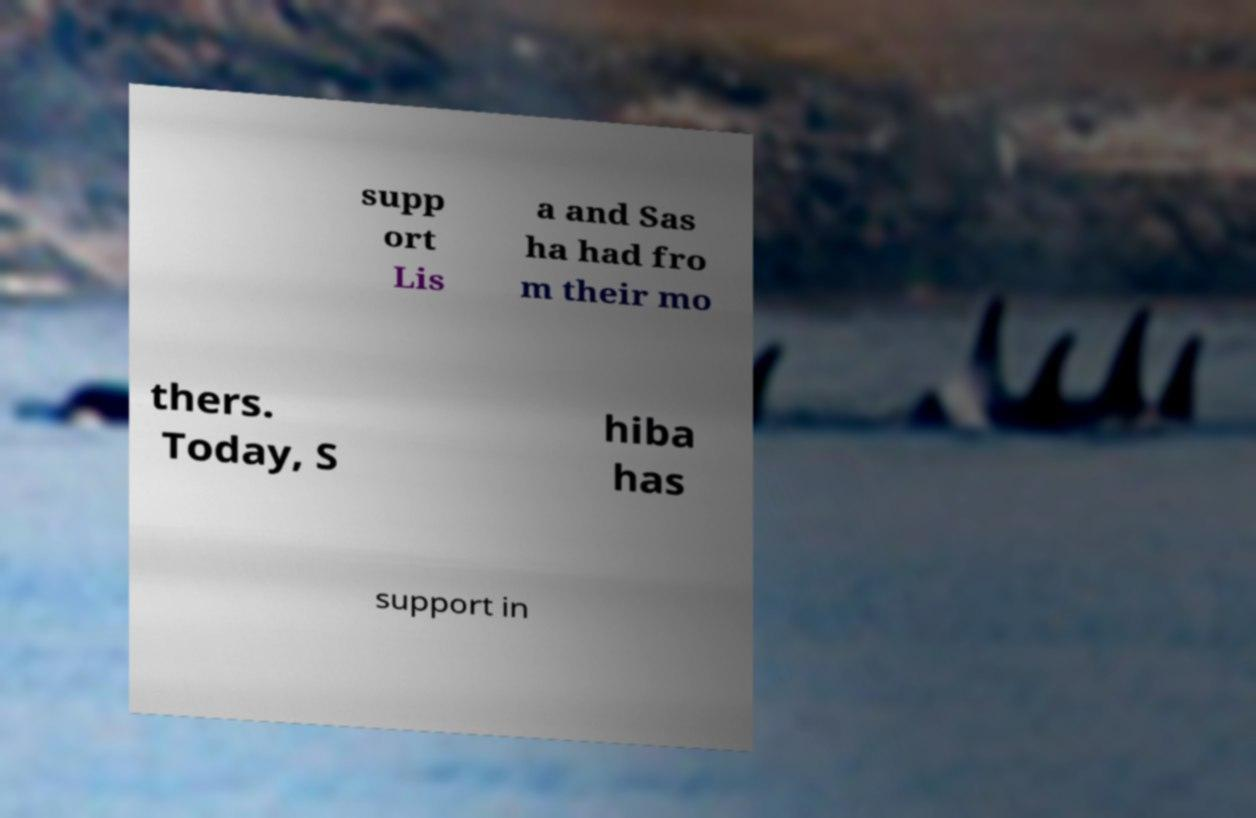Can you accurately transcribe the text from the provided image for me? supp ort Lis a and Sas ha had fro m their mo thers. Today, S hiba has support in 